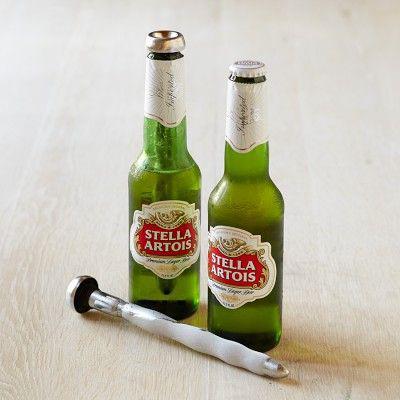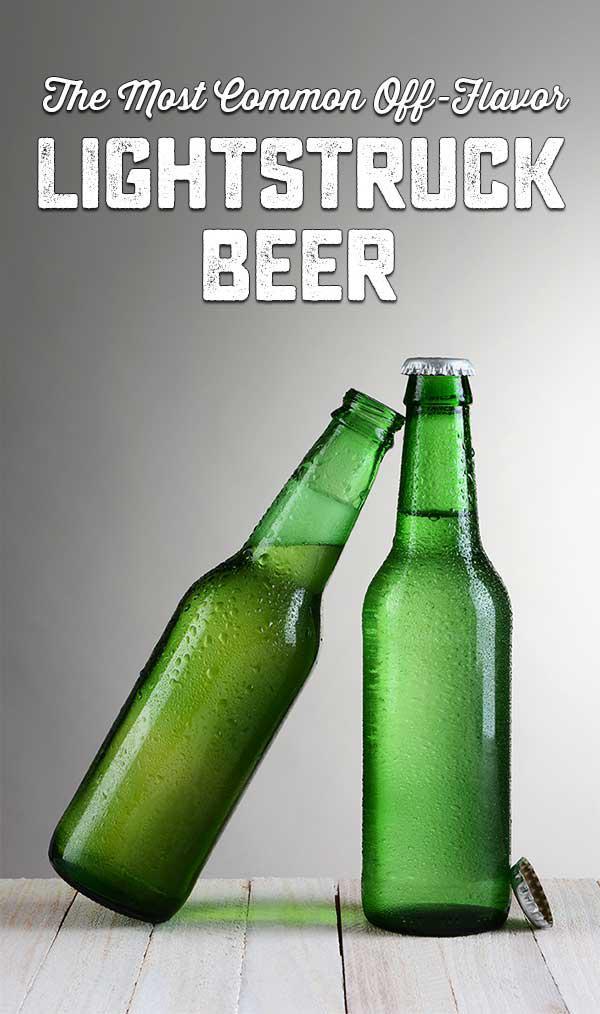The first image is the image on the left, the second image is the image on the right. Considering the images on both sides, is "there are exactly three bottles in the image on the right." valid? Answer yes or no. No. The first image is the image on the left, the second image is the image on the right. Considering the images on both sides, is "One image shows several bottles sticking out of a bucket." valid? Answer yes or no. No. 